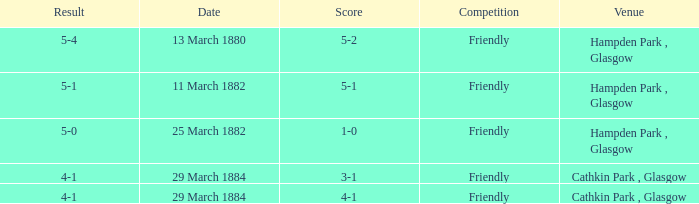Could you help me parse every detail presented in this table? {'header': ['Result', 'Date', 'Score', 'Competition', 'Venue'], 'rows': [['5-4', '13 March 1880', '5-2', 'Friendly', 'Hampden Park , Glasgow'], ['5-1', '11 March 1882', '5-1', 'Friendly', 'Hampden Park , Glasgow'], ['5-0', '25 March 1882', '1-0', 'Friendly', 'Hampden Park , Glasgow'], ['4-1', '29 March 1884', '3-1', 'Friendly', 'Cathkin Park , Glasgow'], ['4-1', '29 March 1884', '4-1', 'Friendly', 'Cathkin Park , Glasgow']]} Which item has a score of 5-1? 5-1. 